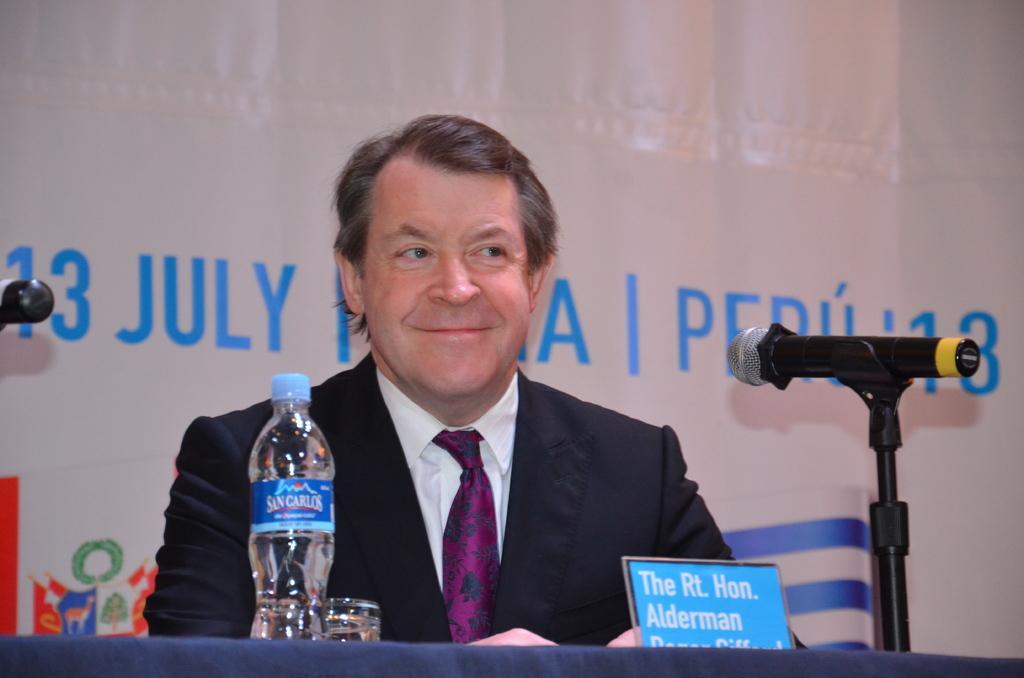Describe this image in one or two sentences. In this image we can see a person sitting beside a table containing a water bottle, a glass, a name board and a mic with stand. On the backside we can see some text on a wall. 